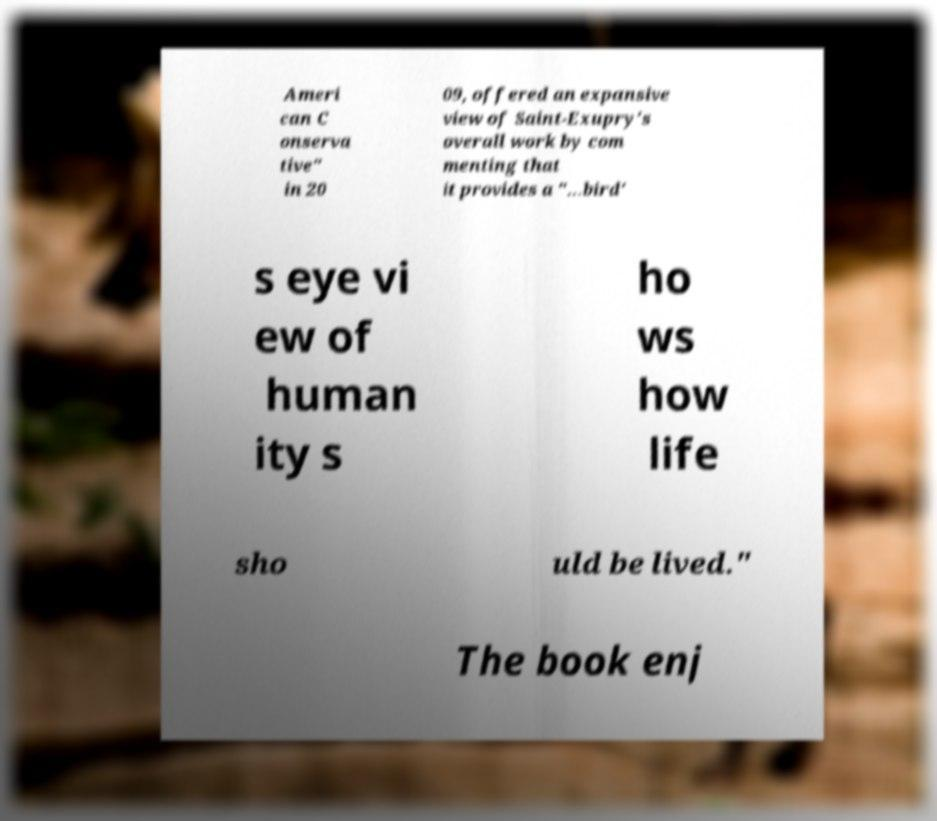Please identify and transcribe the text found in this image. Ameri can C onserva tive" in 20 09, offered an expansive view of Saint-Exupry's overall work by com menting that it provides a "…bird' s eye vi ew of human ity s ho ws how life sho uld be lived." The book enj 